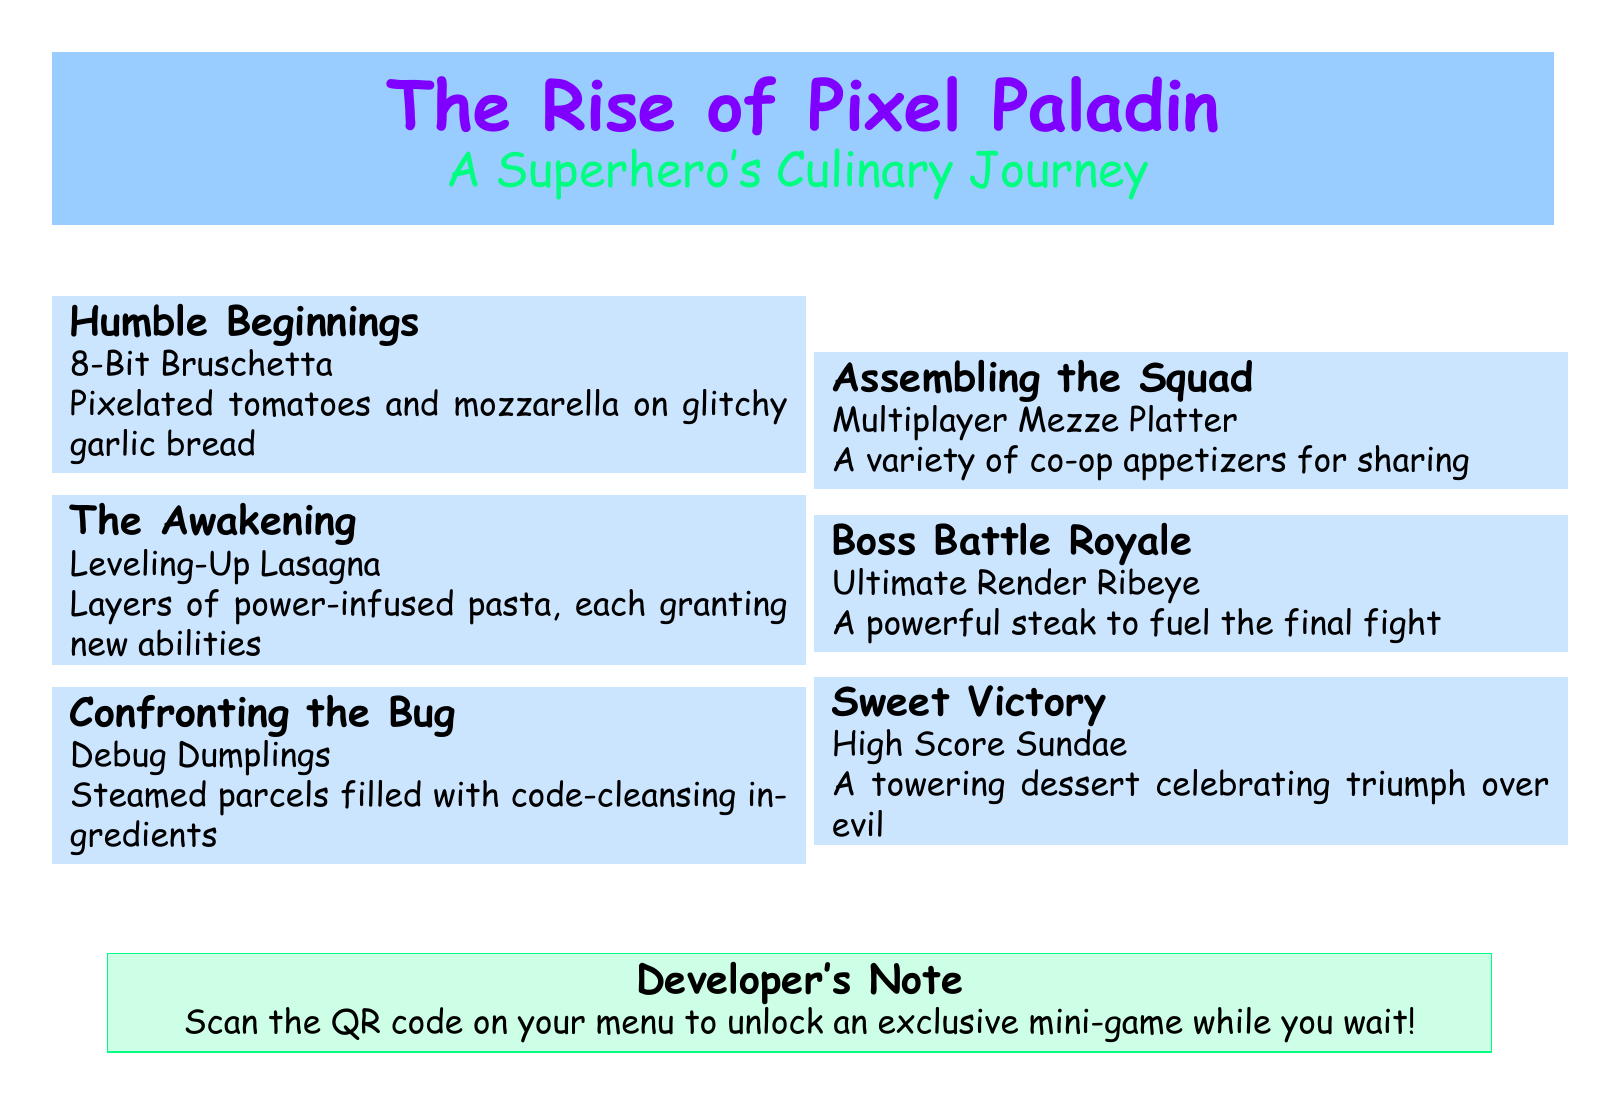What is the title of the menu? The title is prominently displayed at the top of the document, introduced as the superhero's story.
Answer: The Rise of Pixel Paladin What is the first course called? The menu lists the courses in a specific order, with the first being an appetizer.
Answer: Humble Beginnings How much does the Leveling-Up Lasagna cost? Each menu item includes a price to the right of its name.
Answer: $12 What is included in the Debug Dumplings? The description provides insight into the ingredients or theme of each dish.
Answer: Code-cleansing ingredients What type of dessert is offered? The last course refers to a celebratory dessert, hinting at a victory theme.
Answer: High Score Sundae How many courses are listed in total? The document outlines a sequence of events, each representing a course.
Answer: 6 What theme does the menu follow? The entire menu's design and descriptions revolve around a specific concept.
Answer: Superhero's Culinary Journey What do you do to unlock the mini-game? The developer's note suggests an action related to the menu for engagement.
Answer: Scan the QR code What color is used for the title background? The background colors are specified in the document to enhance visual appeal.
Answer: Pixel blue 